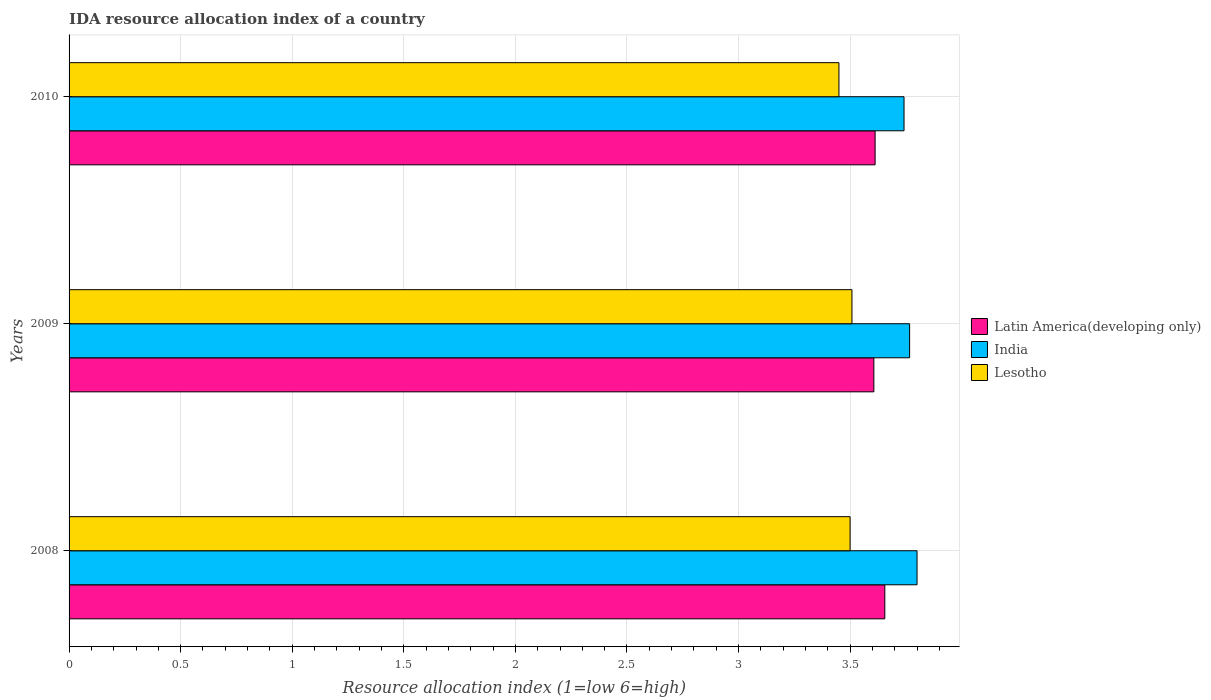How many different coloured bars are there?
Offer a terse response. 3. Are the number of bars per tick equal to the number of legend labels?
Your response must be concise. Yes. Are the number of bars on each tick of the Y-axis equal?
Provide a succinct answer. Yes. In how many cases, is the number of bars for a given year not equal to the number of legend labels?
Make the answer very short. 0. Across all years, what is the maximum IDA resource allocation index in Lesotho?
Keep it short and to the point. 3.51. Across all years, what is the minimum IDA resource allocation index in Latin America(developing only)?
Keep it short and to the point. 3.61. In which year was the IDA resource allocation index in Latin America(developing only) minimum?
Your answer should be compact. 2009. What is the total IDA resource allocation index in India in the graph?
Provide a short and direct response. 11.31. What is the difference between the IDA resource allocation index in India in 2008 and that in 2009?
Give a very brief answer. 0.03. What is the difference between the IDA resource allocation index in India in 2009 and the IDA resource allocation index in Lesotho in 2008?
Provide a succinct answer. 0.27. What is the average IDA resource allocation index in Lesotho per year?
Offer a very short reply. 3.49. In the year 2010, what is the difference between the IDA resource allocation index in Latin America(developing only) and IDA resource allocation index in India?
Your response must be concise. -0.13. What is the ratio of the IDA resource allocation index in Lesotho in 2008 to that in 2010?
Offer a terse response. 1.01. Is the difference between the IDA resource allocation index in Latin America(developing only) in 2008 and 2009 greater than the difference between the IDA resource allocation index in India in 2008 and 2009?
Ensure brevity in your answer.  Yes. What is the difference between the highest and the second highest IDA resource allocation index in Latin America(developing only)?
Offer a terse response. 0.04. What is the difference between the highest and the lowest IDA resource allocation index in Lesotho?
Your response must be concise. 0.06. What does the 3rd bar from the bottom in 2009 represents?
Your answer should be compact. Lesotho. How many bars are there?
Give a very brief answer. 9. Are all the bars in the graph horizontal?
Offer a very short reply. Yes. How many years are there in the graph?
Keep it short and to the point. 3. Are the values on the major ticks of X-axis written in scientific E-notation?
Offer a terse response. No. Does the graph contain any zero values?
Offer a very short reply. No. Does the graph contain grids?
Make the answer very short. Yes. How many legend labels are there?
Give a very brief answer. 3. What is the title of the graph?
Your response must be concise. IDA resource allocation index of a country. What is the label or title of the X-axis?
Ensure brevity in your answer.  Resource allocation index (1=low 6=high). What is the Resource allocation index (1=low 6=high) of Latin America(developing only) in 2008?
Your answer should be very brief. 3.66. What is the Resource allocation index (1=low 6=high) of Latin America(developing only) in 2009?
Offer a terse response. 3.61. What is the Resource allocation index (1=low 6=high) in India in 2009?
Offer a very short reply. 3.77. What is the Resource allocation index (1=low 6=high) of Lesotho in 2009?
Your answer should be very brief. 3.51. What is the Resource allocation index (1=low 6=high) of Latin America(developing only) in 2010?
Your answer should be compact. 3.61. What is the Resource allocation index (1=low 6=high) of India in 2010?
Ensure brevity in your answer.  3.74. What is the Resource allocation index (1=low 6=high) of Lesotho in 2010?
Provide a short and direct response. 3.45. Across all years, what is the maximum Resource allocation index (1=low 6=high) of Latin America(developing only)?
Ensure brevity in your answer.  3.66. Across all years, what is the maximum Resource allocation index (1=low 6=high) in India?
Ensure brevity in your answer.  3.8. Across all years, what is the maximum Resource allocation index (1=low 6=high) of Lesotho?
Your answer should be very brief. 3.51. Across all years, what is the minimum Resource allocation index (1=low 6=high) of Latin America(developing only)?
Ensure brevity in your answer.  3.61. Across all years, what is the minimum Resource allocation index (1=low 6=high) in India?
Offer a very short reply. 3.74. Across all years, what is the minimum Resource allocation index (1=low 6=high) in Lesotho?
Keep it short and to the point. 3.45. What is the total Resource allocation index (1=low 6=high) in Latin America(developing only) in the graph?
Make the answer very short. 10.87. What is the total Resource allocation index (1=low 6=high) of India in the graph?
Give a very brief answer. 11.31. What is the total Resource allocation index (1=low 6=high) in Lesotho in the graph?
Provide a short and direct response. 10.46. What is the difference between the Resource allocation index (1=low 6=high) in Latin America(developing only) in 2008 and that in 2009?
Your answer should be very brief. 0.05. What is the difference between the Resource allocation index (1=low 6=high) of Lesotho in 2008 and that in 2009?
Ensure brevity in your answer.  -0.01. What is the difference between the Resource allocation index (1=low 6=high) in Latin America(developing only) in 2008 and that in 2010?
Make the answer very short. 0.04. What is the difference between the Resource allocation index (1=low 6=high) in India in 2008 and that in 2010?
Make the answer very short. 0.06. What is the difference between the Resource allocation index (1=low 6=high) of Latin America(developing only) in 2009 and that in 2010?
Provide a succinct answer. -0.01. What is the difference between the Resource allocation index (1=low 6=high) of India in 2009 and that in 2010?
Provide a short and direct response. 0.03. What is the difference between the Resource allocation index (1=low 6=high) of Lesotho in 2009 and that in 2010?
Your answer should be very brief. 0.06. What is the difference between the Resource allocation index (1=low 6=high) in Latin America(developing only) in 2008 and the Resource allocation index (1=low 6=high) in India in 2009?
Make the answer very short. -0.11. What is the difference between the Resource allocation index (1=low 6=high) in Latin America(developing only) in 2008 and the Resource allocation index (1=low 6=high) in Lesotho in 2009?
Your response must be concise. 0.15. What is the difference between the Resource allocation index (1=low 6=high) in India in 2008 and the Resource allocation index (1=low 6=high) in Lesotho in 2009?
Keep it short and to the point. 0.29. What is the difference between the Resource allocation index (1=low 6=high) of Latin America(developing only) in 2008 and the Resource allocation index (1=low 6=high) of India in 2010?
Offer a terse response. -0.09. What is the difference between the Resource allocation index (1=low 6=high) in Latin America(developing only) in 2008 and the Resource allocation index (1=low 6=high) in Lesotho in 2010?
Provide a short and direct response. 0.21. What is the difference between the Resource allocation index (1=low 6=high) in India in 2008 and the Resource allocation index (1=low 6=high) in Lesotho in 2010?
Your answer should be compact. 0.35. What is the difference between the Resource allocation index (1=low 6=high) of Latin America(developing only) in 2009 and the Resource allocation index (1=low 6=high) of India in 2010?
Ensure brevity in your answer.  -0.14. What is the difference between the Resource allocation index (1=low 6=high) of Latin America(developing only) in 2009 and the Resource allocation index (1=low 6=high) of Lesotho in 2010?
Offer a very short reply. 0.16. What is the difference between the Resource allocation index (1=low 6=high) of India in 2009 and the Resource allocation index (1=low 6=high) of Lesotho in 2010?
Give a very brief answer. 0.32. What is the average Resource allocation index (1=low 6=high) of Latin America(developing only) per year?
Your answer should be very brief. 3.62. What is the average Resource allocation index (1=low 6=high) of India per year?
Provide a short and direct response. 3.77. What is the average Resource allocation index (1=low 6=high) of Lesotho per year?
Provide a short and direct response. 3.49. In the year 2008, what is the difference between the Resource allocation index (1=low 6=high) in Latin America(developing only) and Resource allocation index (1=low 6=high) in India?
Keep it short and to the point. -0.14. In the year 2008, what is the difference between the Resource allocation index (1=low 6=high) in Latin America(developing only) and Resource allocation index (1=low 6=high) in Lesotho?
Keep it short and to the point. 0.16. In the year 2008, what is the difference between the Resource allocation index (1=low 6=high) of India and Resource allocation index (1=low 6=high) of Lesotho?
Your answer should be very brief. 0.3. In the year 2009, what is the difference between the Resource allocation index (1=low 6=high) of Latin America(developing only) and Resource allocation index (1=low 6=high) of India?
Offer a terse response. -0.16. In the year 2009, what is the difference between the Resource allocation index (1=low 6=high) in Latin America(developing only) and Resource allocation index (1=low 6=high) in Lesotho?
Provide a succinct answer. 0.1. In the year 2009, what is the difference between the Resource allocation index (1=low 6=high) in India and Resource allocation index (1=low 6=high) in Lesotho?
Your answer should be very brief. 0.26. In the year 2010, what is the difference between the Resource allocation index (1=low 6=high) in Latin America(developing only) and Resource allocation index (1=low 6=high) in India?
Your response must be concise. -0.13. In the year 2010, what is the difference between the Resource allocation index (1=low 6=high) of Latin America(developing only) and Resource allocation index (1=low 6=high) of Lesotho?
Your answer should be very brief. 0.16. In the year 2010, what is the difference between the Resource allocation index (1=low 6=high) of India and Resource allocation index (1=low 6=high) of Lesotho?
Offer a terse response. 0.29. What is the ratio of the Resource allocation index (1=low 6=high) in Latin America(developing only) in 2008 to that in 2009?
Ensure brevity in your answer.  1.01. What is the ratio of the Resource allocation index (1=low 6=high) of India in 2008 to that in 2009?
Your answer should be compact. 1.01. What is the ratio of the Resource allocation index (1=low 6=high) of India in 2008 to that in 2010?
Offer a terse response. 1.02. What is the ratio of the Resource allocation index (1=low 6=high) in Lesotho in 2008 to that in 2010?
Give a very brief answer. 1.01. What is the ratio of the Resource allocation index (1=low 6=high) in Latin America(developing only) in 2009 to that in 2010?
Ensure brevity in your answer.  1. What is the ratio of the Resource allocation index (1=low 6=high) in India in 2009 to that in 2010?
Keep it short and to the point. 1.01. What is the ratio of the Resource allocation index (1=low 6=high) of Lesotho in 2009 to that in 2010?
Give a very brief answer. 1.02. What is the difference between the highest and the second highest Resource allocation index (1=low 6=high) in Latin America(developing only)?
Ensure brevity in your answer.  0.04. What is the difference between the highest and the second highest Resource allocation index (1=low 6=high) of Lesotho?
Provide a succinct answer. 0.01. What is the difference between the highest and the lowest Resource allocation index (1=low 6=high) of Latin America(developing only)?
Provide a short and direct response. 0.05. What is the difference between the highest and the lowest Resource allocation index (1=low 6=high) in India?
Offer a very short reply. 0.06. What is the difference between the highest and the lowest Resource allocation index (1=low 6=high) of Lesotho?
Make the answer very short. 0.06. 